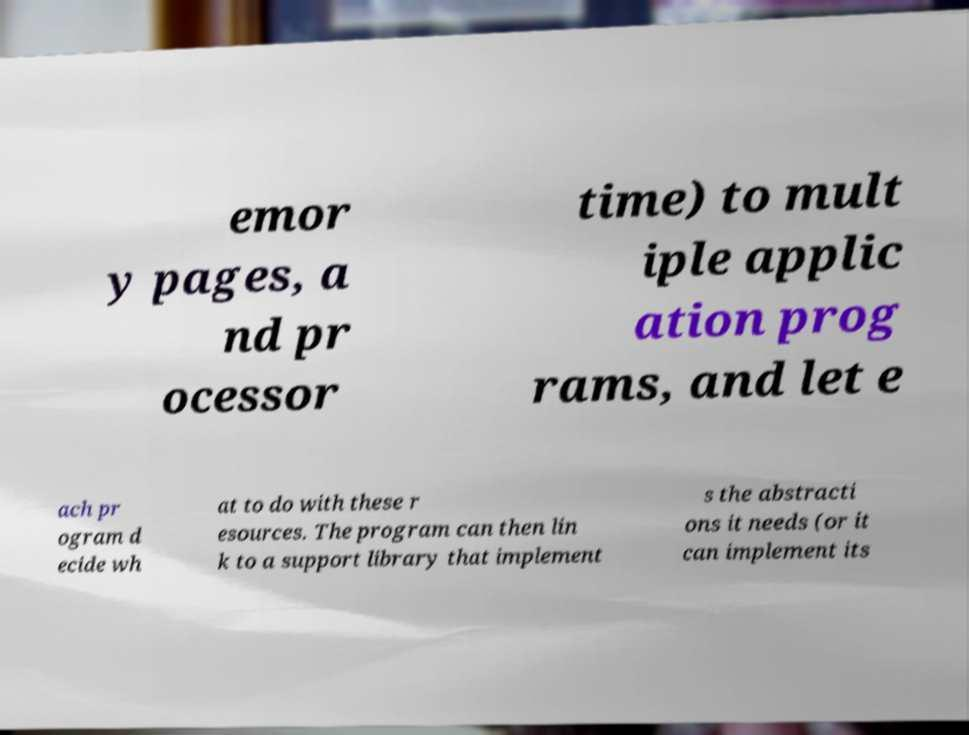Can you accurately transcribe the text from the provided image for me? emor y pages, a nd pr ocessor time) to mult iple applic ation prog rams, and let e ach pr ogram d ecide wh at to do with these r esources. The program can then lin k to a support library that implement s the abstracti ons it needs (or it can implement its 